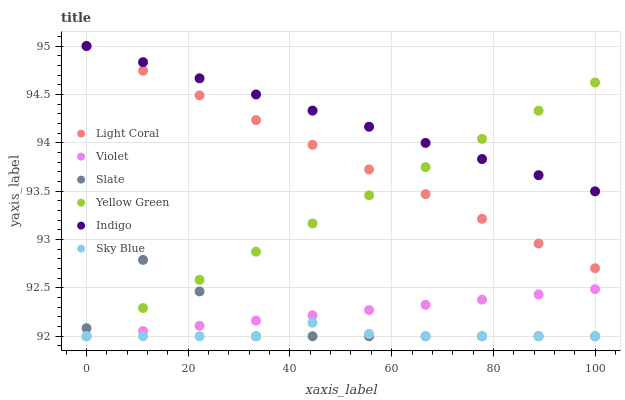Does Sky Blue have the minimum area under the curve?
Answer yes or no. Yes. Does Indigo have the maximum area under the curve?
Answer yes or no. Yes. Does Yellow Green have the minimum area under the curve?
Answer yes or no. No. Does Yellow Green have the maximum area under the curve?
Answer yes or no. No. Is Violet the smoothest?
Answer yes or no. Yes. Is Slate the roughest?
Answer yes or no. Yes. Is Yellow Green the smoothest?
Answer yes or no. No. Is Yellow Green the roughest?
Answer yes or no. No. Does Yellow Green have the lowest value?
Answer yes or no. Yes. Does Light Coral have the lowest value?
Answer yes or no. No. Does Light Coral have the highest value?
Answer yes or no. Yes. Does Yellow Green have the highest value?
Answer yes or no. No. Is Violet less than Indigo?
Answer yes or no. Yes. Is Indigo greater than Slate?
Answer yes or no. Yes. Does Yellow Green intersect Indigo?
Answer yes or no. Yes. Is Yellow Green less than Indigo?
Answer yes or no. No. Is Yellow Green greater than Indigo?
Answer yes or no. No. Does Violet intersect Indigo?
Answer yes or no. No. 